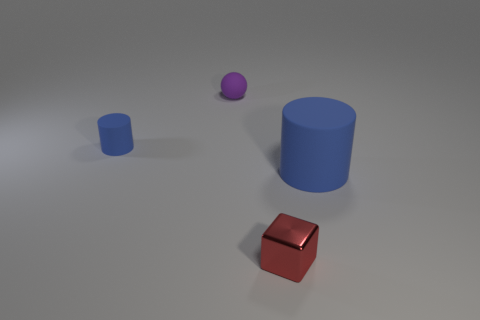Can you infer any particular use for these objects? Are they just random shapes? The objects in the image—a cube, a sphere, and a cylinder—appear to be simple geometric shapes often used in educational contexts to teach about volume, geometry, or to serve as basic models in computer graphics. There's no clear indication that these items have a specific use beyond these educational or illustrative purposes. 